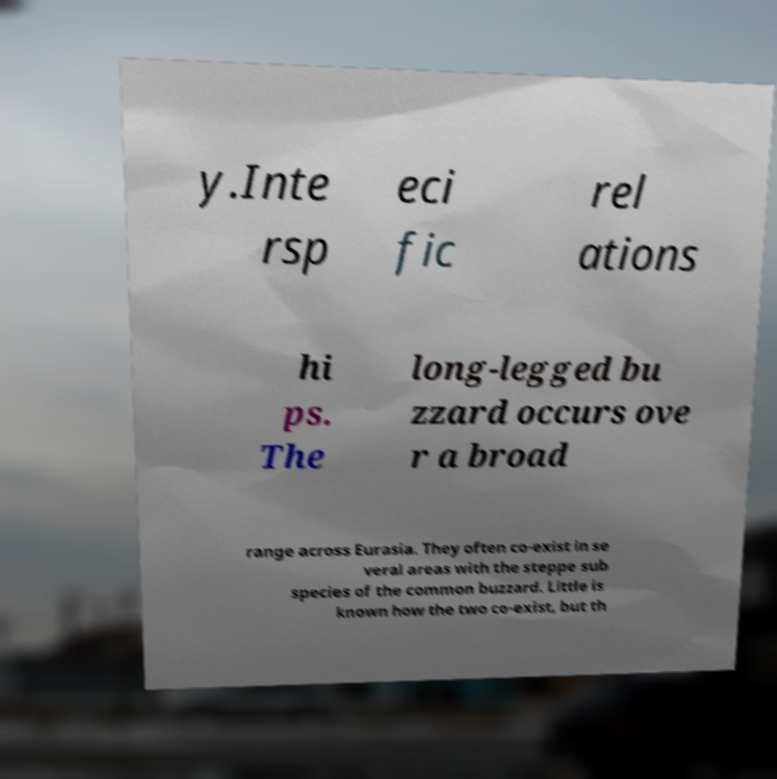Please read and relay the text visible in this image. What does it say? y.Inte rsp eci fic rel ations hi ps. The long-legged bu zzard occurs ove r a broad range across Eurasia. They often co-exist in se veral areas with the steppe sub species of the common buzzard. Little is known how the two co-exist, but th 